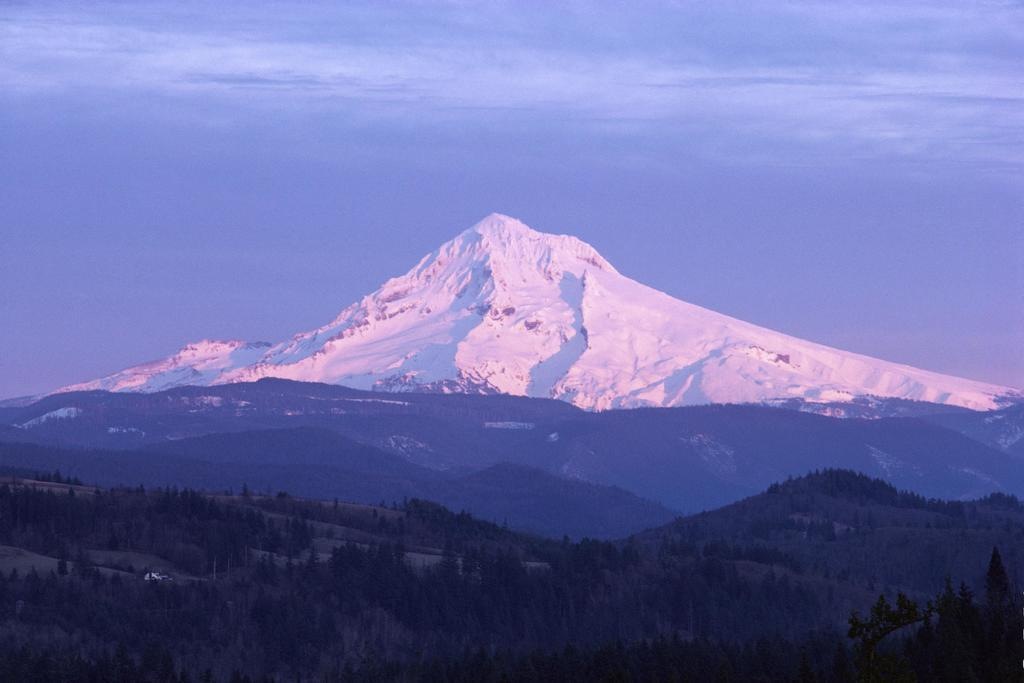What type of landscape is depicted at the bottom of the image? There are hills with grass and trees at the bottom of the image. What can be seen in the background of the image? There is a mountain with snow in the background. What is visible at the top of the image? The sky is visible at the top of the image. What shape is the yak grazing on the grass in the image? There is no yak present in the image. What emotion does the mountain feel when it sees the hills in the image? Mountains do not have emotions, so this question cannot be answered. 